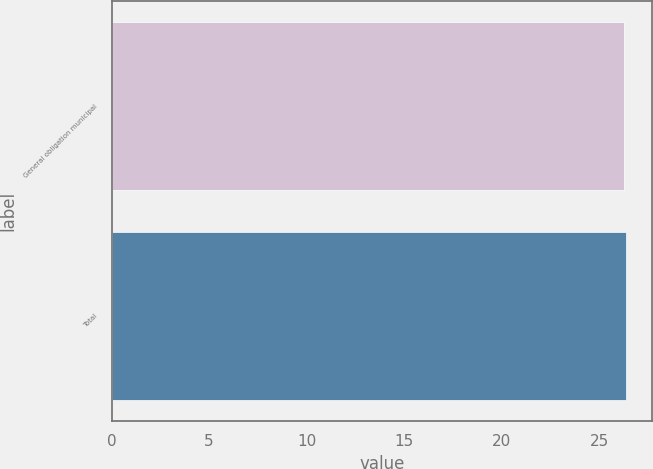Convert chart to OTSL. <chart><loc_0><loc_0><loc_500><loc_500><bar_chart><fcel>General obligation municipal<fcel>Total<nl><fcel>26.3<fcel>26.4<nl></chart> 